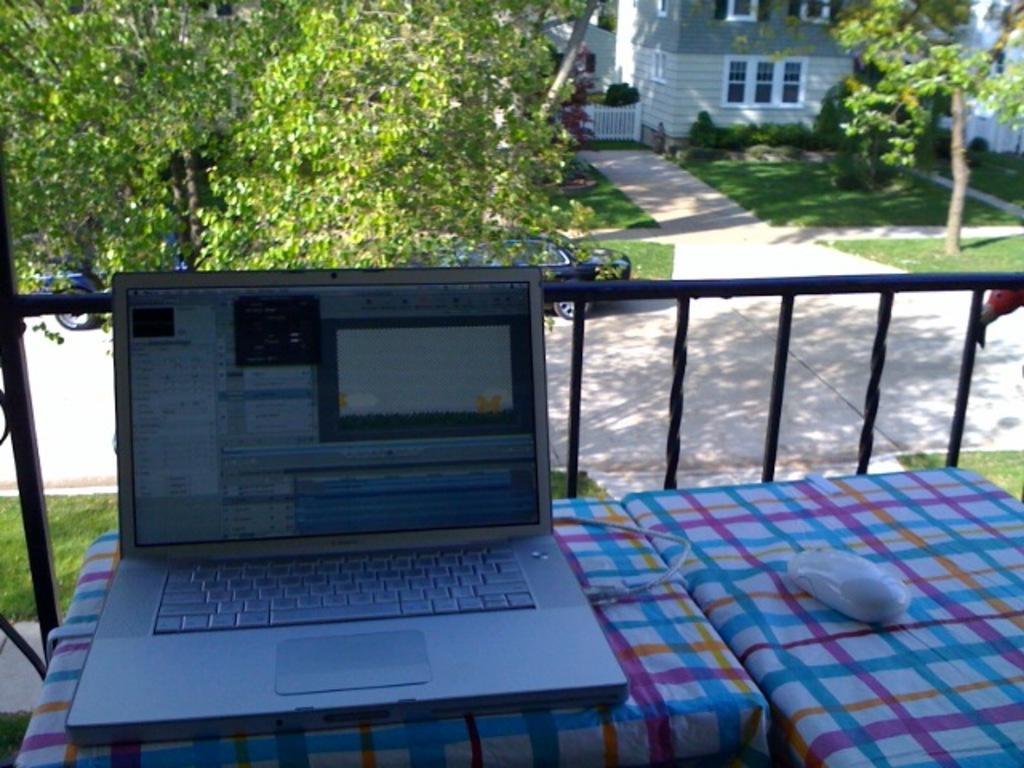Describe this image in one or two sentences. In this image we can see a laptop, connector and a mouse on the tables. We can also see the railing, a group of trees, cars on the ground, grass, some plants, a building with windows and a fence. 